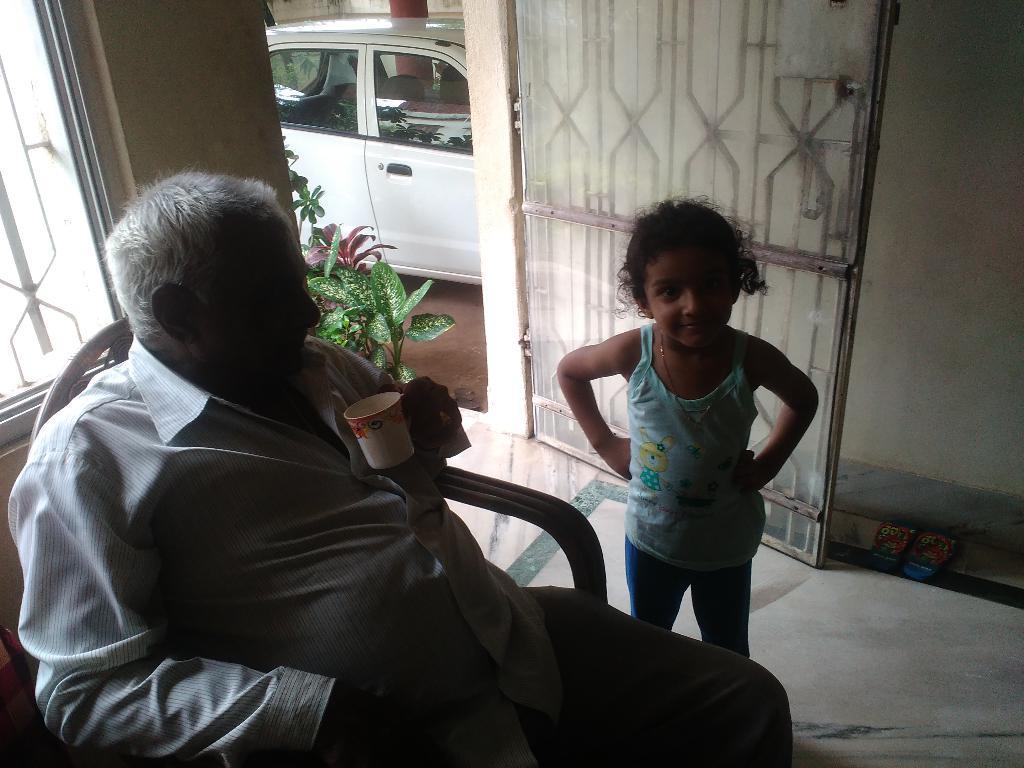In one or two sentences, can you explain what this image depicts? In this image, a girl is standing near the chair. A human is sat on that chair. He is holding a cup in his hand. On right side, we can see slippers,floor, cream color wall. Glass door in the middle, car, some plants. Left side, we can see glass window and wall. 